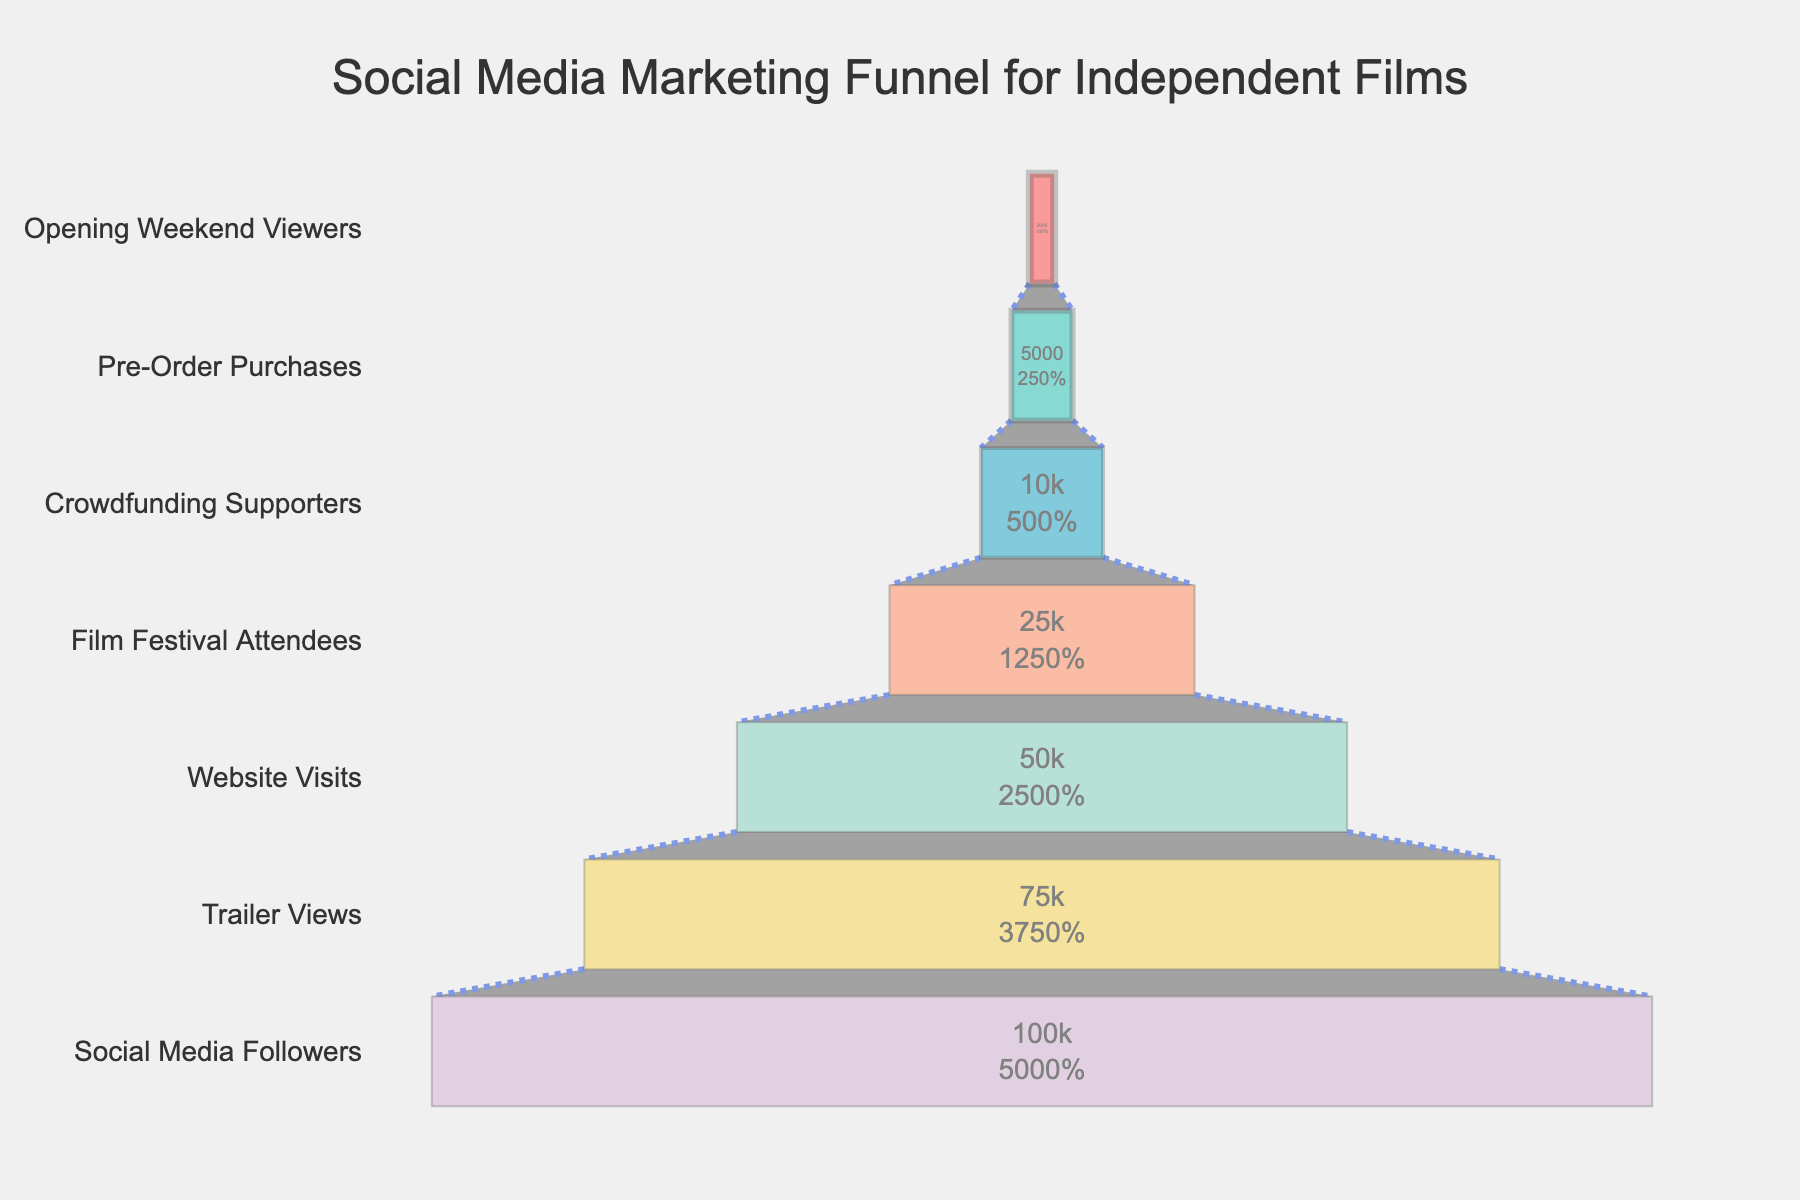What's the title of the figure? The title is prominently displayed at the top of the figure, indicating the main topic of the visual representation.
Answer: Social Media Marketing Funnel for Independent Films What is the stage with the highest number of people? The funnel chart shows the number of people at each stage descending from the top to the bottom. The stage at the top has the highest number.
Answer: Social Media Followers How many people are estimated to have viewed the trailer? The funnel chart indicates the number of people at each stage with labels. The second entry from the top provides this information.
Answer: 75,000 What is the percentage drop from Website Visits to Film Festival Attendees? The number of people for Website Visits is 50,000, and for Film Festival Attendees, it's 25,000. The percentage drop can be calculated as [(50,000 - 25,000) / 50,000] * 100.
Answer: 50% Which stages have fewer than 10,000 people? By examining the chart, you can identify the stages from the color-coded bars where the people count is less than 10,000.
Answer: Crowdfunding Supporters, Pre-Order Purchases, Opening Weekend Viewers What's the total number of people from Film Festival Attendees to Opening Weekend Viewers? Add the number of people from Film Festival Attendees (25,000), Crowdfunding Supporters (10,000), Pre-Order Purchases (5,000), and Opening Weekend Viewers (2,000). Total = 25,000 + 10,000 + 5,000 + 2,000.
Answer: 42,000 Which stages show a decrease greater than 50% compared to the previous stage? By comparing the figures between each consecutive stage and calculating the decrease percentage, you can determine which decreases exceed 50%.
Answer: Website Visits to Film Festival Attendees, Crowdfunding Supporters to Pre-Order Purchases What is the ratio of Trailer Views to Opening Weekend Viewers? Find the number of people for each stage (75,000 for Trailer Views and 2,000 for Opening Weekend Viewers) and calculate the ratio by dividing the two values.
Answer: 37.5 How many stages are represented in the funnel chart? Count the number of distinct stages labeled on the y-axis of the funnel chart.
Answer: 7 What percentage of Social Media Followers become Pre-Order Purchases? The number of Social Media Followers is 100,000, and the number of Pre-Order Purchases is 5,000. The percentage can be calculated as (5,000 / 100,000) * 100.
Answer: 5% 